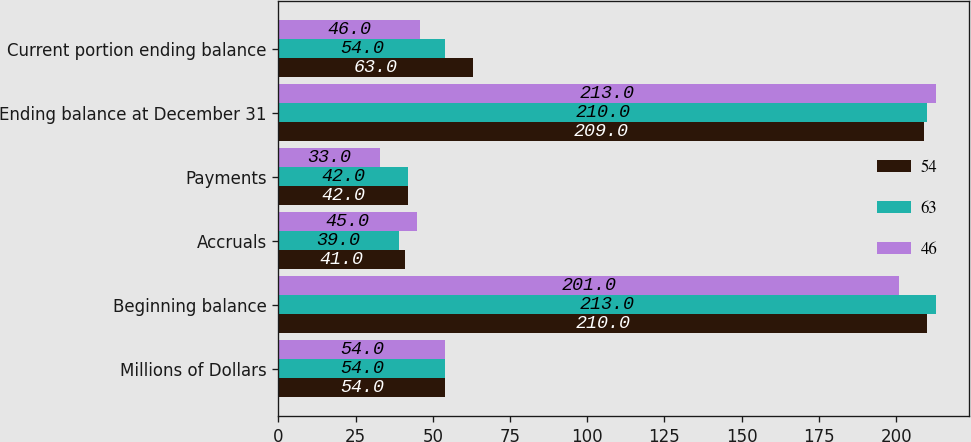Convert chart to OTSL. <chart><loc_0><loc_0><loc_500><loc_500><stacked_bar_chart><ecel><fcel>Millions of Dollars<fcel>Beginning balance<fcel>Accruals<fcel>Payments<fcel>Ending balance at December 31<fcel>Current portion ending balance<nl><fcel>54<fcel>54<fcel>210<fcel>41<fcel>42<fcel>209<fcel>63<nl><fcel>63<fcel>54<fcel>213<fcel>39<fcel>42<fcel>210<fcel>54<nl><fcel>46<fcel>54<fcel>201<fcel>45<fcel>33<fcel>213<fcel>46<nl></chart> 